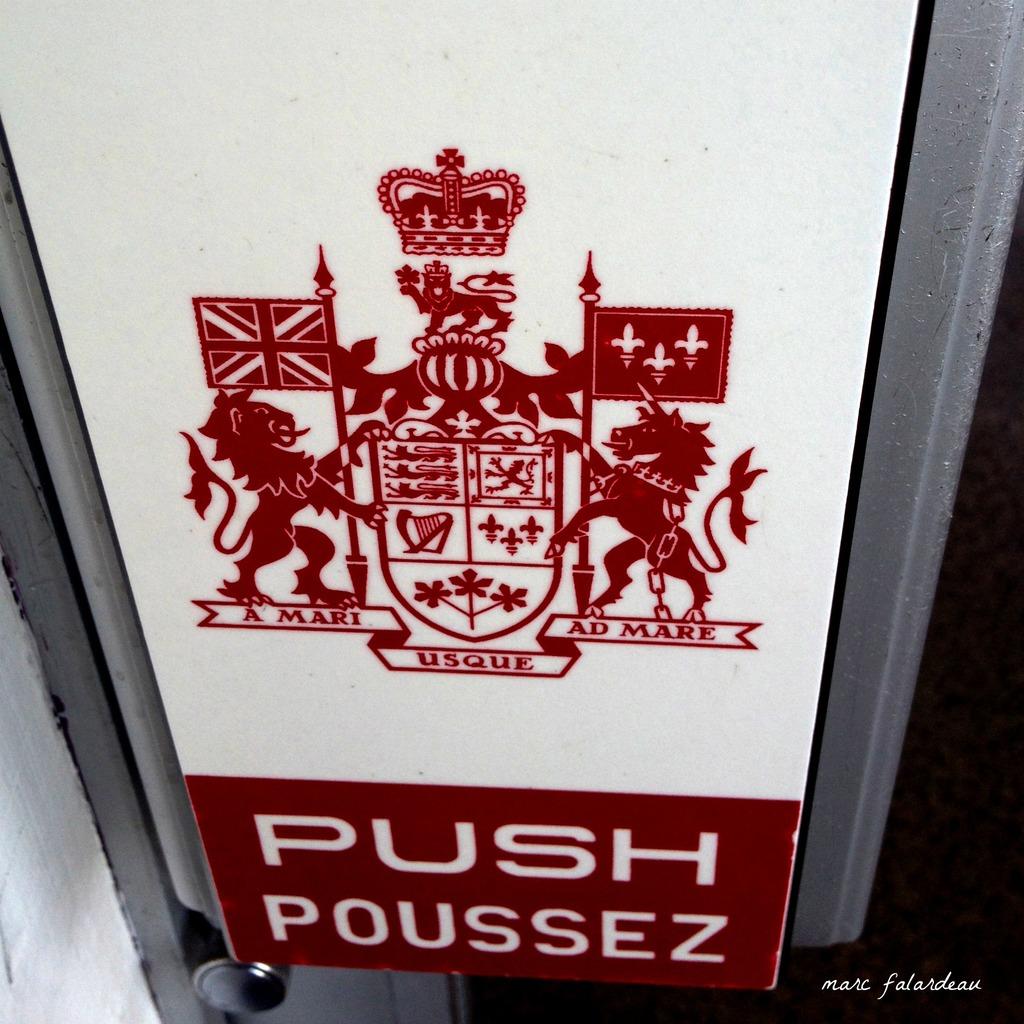Is this door a push or pull?
Offer a terse response. Push. What is written under the animal on the right?
Give a very brief answer. Ad mare. 